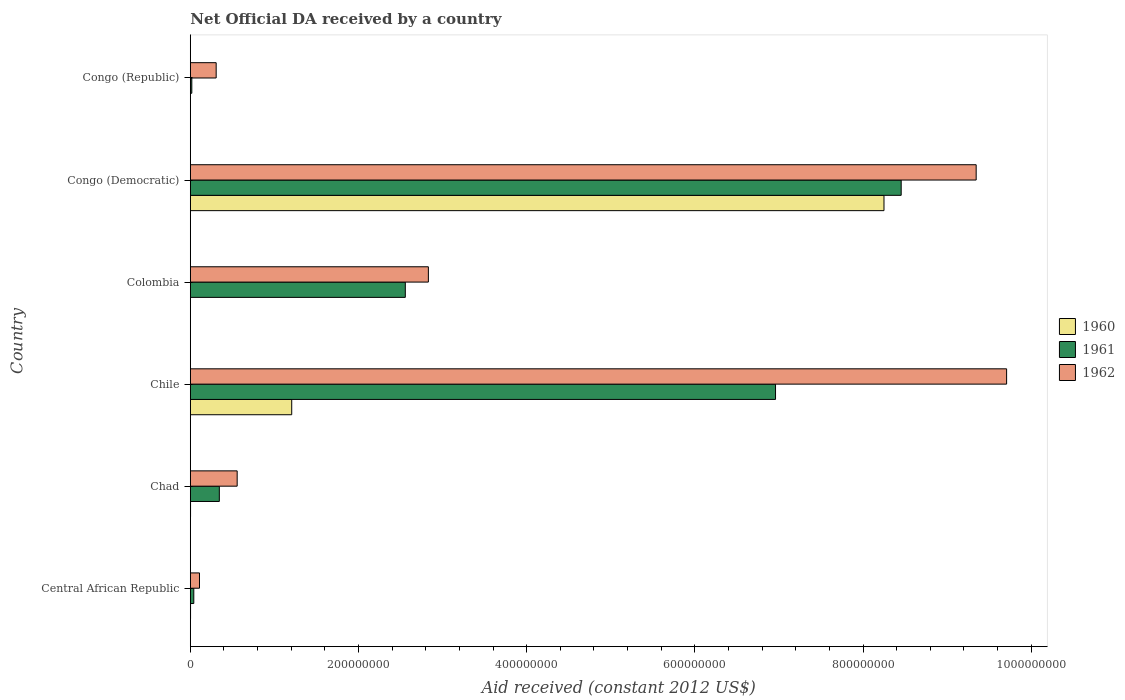How many groups of bars are there?
Make the answer very short. 6. Are the number of bars per tick equal to the number of legend labels?
Offer a very short reply. No. Are the number of bars on each tick of the Y-axis equal?
Make the answer very short. No. What is the label of the 2nd group of bars from the top?
Ensure brevity in your answer.  Congo (Democratic). What is the net official development assistance aid received in 1962 in Colombia?
Provide a succinct answer. 2.83e+08. Across all countries, what is the maximum net official development assistance aid received in 1960?
Provide a short and direct response. 8.25e+08. Across all countries, what is the minimum net official development assistance aid received in 1961?
Ensure brevity in your answer.  1.80e+06. What is the total net official development assistance aid received in 1962 in the graph?
Provide a succinct answer. 2.29e+09. What is the difference between the net official development assistance aid received in 1960 in Central African Republic and that in Congo (Republic)?
Give a very brief answer. 8.00e+04. What is the difference between the net official development assistance aid received in 1960 in Chad and the net official development assistance aid received in 1962 in Colombia?
Your answer should be very brief. -2.83e+08. What is the average net official development assistance aid received in 1960 per country?
Your answer should be very brief. 1.58e+08. What is the difference between the net official development assistance aid received in 1962 and net official development assistance aid received in 1960 in Congo (Democratic)?
Offer a very short reply. 1.10e+08. What is the ratio of the net official development assistance aid received in 1962 in Chile to that in Congo (Democratic)?
Provide a succinct answer. 1.04. Is the difference between the net official development assistance aid received in 1962 in Chile and Congo (Republic) greater than the difference between the net official development assistance aid received in 1960 in Chile and Congo (Republic)?
Offer a terse response. Yes. What is the difference between the highest and the second highest net official development assistance aid received in 1962?
Ensure brevity in your answer.  3.62e+07. What is the difference between the highest and the lowest net official development assistance aid received in 1960?
Give a very brief answer. 8.25e+08. In how many countries, is the net official development assistance aid received in 1960 greater than the average net official development assistance aid received in 1960 taken over all countries?
Give a very brief answer. 1. How many bars are there?
Your answer should be very brief. 17. How many countries are there in the graph?
Provide a succinct answer. 6. Are the values on the major ticks of X-axis written in scientific E-notation?
Your answer should be compact. No. Does the graph contain grids?
Give a very brief answer. No. Where does the legend appear in the graph?
Provide a short and direct response. Center right. How many legend labels are there?
Your answer should be very brief. 3. What is the title of the graph?
Ensure brevity in your answer.  Net Official DA received by a country. What is the label or title of the X-axis?
Your answer should be compact. Aid received (constant 2012 US$). What is the Aid received (constant 2012 US$) in 1961 in Central African Republic?
Provide a short and direct response. 4.17e+06. What is the Aid received (constant 2012 US$) in 1962 in Central African Republic?
Make the answer very short. 1.09e+07. What is the Aid received (constant 2012 US$) in 1960 in Chad?
Make the answer very short. 3.00e+05. What is the Aid received (constant 2012 US$) of 1961 in Chad?
Offer a very short reply. 3.45e+07. What is the Aid received (constant 2012 US$) of 1962 in Chad?
Your answer should be very brief. 5.57e+07. What is the Aid received (constant 2012 US$) in 1960 in Chile?
Give a very brief answer. 1.21e+08. What is the Aid received (constant 2012 US$) in 1961 in Chile?
Provide a succinct answer. 6.96e+08. What is the Aid received (constant 2012 US$) in 1962 in Chile?
Make the answer very short. 9.71e+08. What is the Aid received (constant 2012 US$) in 1961 in Colombia?
Your answer should be compact. 2.56e+08. What is the Aid received (constant 2012 US$) of 1962 in Colombia?
Offer a very short reply. 2.83e+08. What is the Aid received (constant 2012 US$) in 1960 in Congo (Democratic)?
Keep it short and to the point. 8.25e+08. What is the Aid received (constant 2012 US$) in 1961 in Congo (Democratic)?
Keep it short and to the point. 8.45e+08. What is the Aid received (constant 2012 US$) of 1962 in Congo (Democratic)?
Keep it short and to the point. 9.35e+08. What is the Aid received (constant 2012 US$) of 1961 in Congo (Republic)?
Offer a terse response. 1.80e+06. What is the Aid received (constant 2012 US$) of 1962 in Congo (Republic)?
Offer a very short reply. 3.08e+07. Across all countries, what is the maximum Aid received (constant 2012 US$) in 1960?
Ensure brevity in your answer.  8.25e+08. Across all countries, what is the maximum Aid received (constant 2012 US$) in 1961?
Provide a short and direct response. 8.45e+08. Across all countries, what is the maximum Aid received (constant 2012 US$) in 1962?
Keep it short and to the point. 9.71e+08. Across all countries, what is the minimum Aid received (constant 2012 US$) of 1960?
Offer a terse response. 0. Across all countries, what is the minimum Aid received (constant 2012 US$) in 1961?
Provide a short and direct response. 1.80e+06. Across all countries, what is the minimum Aid received (constant 2012 US$) of 1962?
Your answer should be compact. 1.09e+07. What is the total Aid received (constant 2012 US$) of 1960 in the graph?
Provide a short and direct response. 9.46e+08. What is the total Aid received (constant 2012 US$) in 1961 in the graph?
Ensure brevity in your answer.  1.84e+09. What is the total Aid received (constant 2012 US$) of 1962 in the graph?
Offer a very short reply. 2.29e+09. What is the difference between the Aid received (constant 2012 US$) in 1961 in Central African Republic and that in Chad?
Make the answer very short. -3.04e+07. What is the difference between the Aid received (constant 2012 US$) of 1962 in Central African Republic and that in Chad?
Give a very brief answer. -4.48e+07. What is the difference between the Aid received (constant 2012 US$) of 1960 in Central African Republic and that in Chile?
Your answer should be compact. -1.20e+08. What is the difference between the Aid received (constant 2012 US$) of 1961 in Central African Republic and that in Chile?
Your response must be concise. -6.92e+08. What is the difference between the Aid received (constant 2012 US$) in 1962 in Central African Republic and that in Chile?
Provide a succinct answer. -9.60e+08. What is the difference between the Aid received (constant 2012 US$) in 1961 in Central African Republic and that in Colombia?
Keep it short and to the point. -2.52e+08. What is the difference between the Aid received (constant 2012 US$) of 1962 in Central African Republic and that in Colombia?
Offer a terse response. -2.72e+08. What is the difference between the Aid received (constant 2012 US$) in 1960 in Central African Republic and that in Congo (Democratic)?
Offer a very short reply. -8.25e+08. What is the difference between the Aid received (constant 2012 US$) of 1961 in Central African Republic and that in Congo (Democratic)?
Make the answer very short. -8.41e+08. What is the difference between the Aid received (constant 2012 US$) in 1962 in Central African Republic and that in Congo (Democratic)?
Offer a terse response. -9.24e+08. What is the difference between the Aid received (constant 2012 US$) of 1960 in Central African Republic and that in Congo (Republic)?
Ensure brevity in your answer.  8.00e+04. What is the difference between the Aid received (constant 2012 US$) in 1961 in Central African Republic and that in Congo (Republic)?
Offer a terse response. 2.37e+06. What is the difference between the Aid received (constant 2012 US$) in 1962 in Central African Republic and that in Congo (Republic)?
Offer a terse response. -1.98e+07. What is the difference between the Aid received (constant 2012 US$) of 1960 in Chad and that in Chile?
Make the answer very short. -1.20e+08. What is the difference between the Aid received (constant 2012 US$) in 1961 in Chad and that in Chile?
Give a very brief answer. -6.61e+08. What is the difference between the Aid received (constant 2012 US$) of 1962 in Chad and that in Chile?
Keep it short and to the point. -9.15e+08. What is the difference between the Aid received (constant 2012 US$) in 1961 in Chad and that in Colombia?
Your answer should be compact. -2.21e+08. What is the difference between the Aid received (constant 2012 US$) of 1962 in Chad and that in Colombia?
Give a very brief answer. -2.27e+08. What is the difference between the Aid received (constant 2012 US$) of 1960 in Chad and that in Congo (Democratic)?
Your answer should be compact. -8.25e+08. What is the difference between the Aid received (constant 2012 US$) of 1961 in Chad and that in Congo (Democratic)?
Ensure brevity in your answer.  -8.11e+08. What is the difference between the Aid received (constant 2012 US$) of 1962 in Chad and that in Congo (Democratic)?
Provide a short and direct response. -8.79e+08. What is the difference between the Aid received (constant 2012 US$) of 1961 in Chad and that in Congo (Republic)?
Offer a terse response. 3.27e+07. What is the difference between the Aid received (constant 2012 US$) of 1962 in Chad and that in Congo (Republic)?
Your response must be concise. 2.50e+07. What is the difference between the Aid received (constant 2012 US$) of 1961 in Chile and that in Colombia?
Provide a succinct answer. 4.40e+08. What is the difference between the Aid received (constant 2012 US$) in 1962 in Chile and that in Colombia?
Offer a terse response. 6.88e+08. What is the difference between the Aid received (constant 2012 US$) of 1960 in Chile and that in Congo (Democratic)?
Keep it short and to the point. -7.04e+08. What is the difference between the Aid received (constant 2012 US$) of 1961 in Chile and that in Congo (Democratic)?
Make the answer very short. -1.49e+08. What is the difference between the Aid received (constant 2012 US$) in 1962 in Chile and that in Congo (Democratic)?
Your answer should be very brief. 3.62e+07. What is the difference between the Aid received (constant 2012 US$) in 1960 in Chile and that in Congo (Republic)?
Your answer should be compact. 1.20e+08. What is the difference between the Aid received (constant 2012 US$) in 1961 in Chile and that in Congo (Republic)?
Ensure brevity in your answer.  6.94e+08. What is the difference between the Aid received (constant 2012 US$) of 1962 in Chile and that in Congo (Republic)?
Provide a short and direct response. 9.40e+08. What is the difference between the Aid received (constant 2012 US$) in 1961 in Colombia and that in Congo (Democratic)?
Your answer should be very brief. -5.90e+08. What is the difference between the Aid received (constant 2012 US$) in 1962 in Colombia and that in Congo (Democratic)?
Offer a very short reply. -6.51e+08. What is the difference between the Aid received (constant 2012 US$) of 1961 in Colombia and that in Congo (Republic)?
Provide a succinct answer. 2.54e+08. What is the difference between the Aid received (constant 2012 US$) in 1962 in Colombia and that in Congo (Republic)?
Give a very brief answer. 2.52e+08. What is the difference between the Aid received (constant 2012 US$) in 1960 in Congo (Democratic) and that in Congo (Republic)?
Keep it short and to the point. 8.25e+08. What is the difference between the Aid received (constant 2012 US$) in 1961 in Congo (Democratic) and that in Congo (Republic)?
Make the answer very short. 8.44e+08. What is the difference between the Aid received (constant 2012 US$) in 1962 in Congo (Democratic) and that in Congo (Republic)?
Offer a terse response. 9.04e+08. What is the difference between the Aid received (constant 2012 US$) of 1960 in Central African Republic and the Aid received (constant 2012 US$) of 1961 in Chad?
Your answer should be compact. -3.42e+07. What is the difference between the Aid received (constant 2012 US$) in 1960 in Central African Republic and the Aid received (constant 2012 US$) in 1962 in Chad?
Give a very brief answer. -5.54e+07. What is the difference between the Aid received (constant 2012 US$) in 1961 in Central African Republic and the Aid received (constant 2012 US$) in 1962 in Chad?
Provide a succinct answer. -5.16e+07. What is the difference between the Aid received (constant 2012 US$) of 1960 in Central African Republic and the Aid received (constant 2012 US$) of 1961 in Chile?
Make the answer very short. -6.96e+08. What is the difference between the Aid received (constant 2012 US$) of 1960 in Central African Republic and the Aid received (constant 2012 US$) of 1962 in Chile?
Provide a short and direct response. -9.70e+08. What is the difference between the Aid received (constant 2012 US$) of 1961 in Central African Republic and the Aid received (constant 2012 US$) of 1962 in Chile?
Make the answer very short. -9.67e+08. What is the difference between the Aid received (constant 2012 US$) of 1960 in Central African Republic and the Aid received (constant 2012 US$) of 1961 in Colombia?
Provide a short and direct response. -2.55e+08. What is the difference between the Aid received (constant 2012 US$) in 1960 in Central African Republic and the Aid received (constant 2012 US$) in 1962 in Colombia?
Offer a very short reply. -2.83e+08. What is the difference between the Aid received (constant 2012 US$) of 1961 in Central African Republic and the Aid received (constant 2012 US$) of 1962 in Colombia?
Make the answer very short. -2.79e+08. What is the difference between the Aid received (constant 2012 US$) in 1960 in Central African Republic and the Aid received (constant 2012 US$) in 1961 in Congo (Democratic)?
Offer a terse response. -8.45e+08. What is the difference between the Aid received (constant 2012 US$) of 1960 in Central African Republic and the Aid received (constant 2012 US$) of 1962 in Congo (Democratic)?
Make the answer very short. -9.34e+08. What is the difference between the Aid received (constant 2012 US$) in 1961 in Central African Republic and the Aid received (constant 2012 US$) in 1962 in Congo (Democratic)?
Give a very brief answer. -9.30e+08. What is the difference between the Aid received (constant 2012 US$) in 1960 in Central African Republic and the Aid received (constant 2012 US$) in 1961 in Congo (Republic)?
Your response must be concise. -1.50e+06. What is the difference between the Aid received (constant 2012 US$) in 1960 in Central African Republic and the Aid received (constant 2012 US$) in 1962 in Congo (Republic)?
Provide a succinct answer. -3.05e+07. What is the difference between the Aid received (constant 2012 US$) of 1961 in Central African Republic and the Aid received (constant 2012 US$) of 1962 in Congo (Republic)?
Your answer should be very brief. -2.66e+07. What is the difference between the Aid received (constant 2012 US$) of 1960 in Chad and the Aid received (constant 2012 US$) of 1961 in Chile?
Your answer should be very brief. -6.96e+08. What is the difference between the Aid received (constant 2012 US$) in 1960 in Chad and the Aid received (constant 2012 US$) in 1962 in Chile?
Offer a very short reply. -9.70e+08. What is the difference between the Aid received (constant 2012 US$) of 1961 in Chad and the Aid received (constant 2012 US$) of 1962 in Chile?
Your response must be concise. -9.36e+08. What is the difference between the Aid received (constant 2012 US$) of 1960 in Chad and the Aid received (constant 2012 US$) of 1961 in Colombia?
Provide a short and direct response. -2.55e+08. What is the difference between the Aid received (constant 2012 US$) in 1960 in Chad and the Aid received (constant 2012 US$) in 1962 in Colombia?
Offer a terse response. -2.83e+08. What is the difference between the Aid received (constant 2012 US$) in 1961 in Chad and the Aid received (constant 2012 US$) in 1962 in Colombia?
Your answer should be compact. -2.49e+08. What is the difference between the Aid received (constant 2012 US$) of 1960 in Chad and the Aid received (constant 2012 US$) of 1961 in Congo (Democratic)?
Your answer should be very brief. -8.45e+08. What is the difference between the Aid received (constant 2012 US$) of 1960 in Chad and the Aid received (constant 2012 US$) of 1962 in Congo (Democratic)?
Offer a terse response. -9.34e+08. What is the difference between the Aid received (constant 2012 US$) of 1961 in Chad and the Aid received (constant 2012 US$) of 1962 in Congo (Democratic)?
Your answer should be very brief. -9.00e+08. What is the difference between the Aid received (constant 2012 US$) of 1960 in Chad and the Aid received (constant 2012 US$) of 1961 in Congo (Republic)?
Provide a short and direct response. -1.50e+06. What is the difference between the Aid received (constant 2012 US$) in 1960 in Chad and the Aid received (constant 2012 US$) in 1962 in Congo (Republic)?
Ensure brevity in your answer.  -3.05e+07. What is the difference between the Aid received (constant 2012 US$) in 1961 in Chad and the Aid received (constant 2012 US$) in 1962 in Congo (Republic)?
Make the answer very short. 3.75e+06. What is the difference between the Aid received (constant 2012 US$) in 1960 in Chile and the Aid received (constant 2012 US$) in 1961 in Colombia?
Your answer should be very brief. -1.35e+08. What is the difference between the Aid received (constant 2012 US$) of 1960 in Chile and the Aid received (constant 2012 US$) of 1962 in Colombia?
Your answer should be very brief. -1.63e+08. What is the difference between the Aid received (constant 2012 US$) in 1961 in Chile and the Aid received (constant 2012 US$) in 1962 in Colombia?
Your answer should be compact. 4.13e+08. What is the difference between the Aid received (constant 2012 US$) of 1960 in Chile and the Aid received (constant 2012 US$) of 1961 in Congo (Democratic)?
Provide a succinct answer. -7.25e+08. What is the difference between the Aid received (constant 2012 US$) in 1960 in Chile and the Aid received (constant 2012 US$) in 1962 in Congo (Democratic)?
Give a very brief answer. -8.14e+08. What is the difference between the Aid received (constant 2012 US$) in 1961 in Chile and the Aid received (constant 2012 US$) in 1962 in Congo (Democratic)?
Your response must be concise. -2.39e+08. What is the difference between the Aid received (constant 2012 US$) in 1960 in Chile and the Aid received (constant 2012 US$) in 1961 in Congo (Republic)?
Provide a short and direct response. 1.19e+08. What is the difference between the Aid received (constant 2012 US$) in 1960 in Chile and the Aid received (constant 2012 US$) in 1962 in Congo (Republic)?
Make the answer very short. 8.98e+07. What is the difference between the Aid received (constant 2012 US$) in 1961 in Chile and the Aid received (constant 2012 US$) in 1962 in Congo (Republic)?
Provide a short and direct response. 6.65e+08. What is the difference between the Aid received (constant 2012 US$) in 1961 in Colombia and the Aid received (constant 2012 US$) in 1962 in Congo (Democratic)?
Ensure brevity in your answer.  -6.79e+08. What is the difference between the Aid received (constant 2012 US$) in 1961 in Colombia and the Aid received (constant 2012 US$) in 1962 in Congo (Republic)?
Offer a very short reply. 2.25e+08. What is the difference between the Aid received (constant 2012 US$) of 1960 in Congo (Democratic) and the Aid received (constant 2012 US$) of 1961 in Congo (Republic)?
Ensure brevity in your answer.  8.23e+08. What is the difference between the Aid received (constant 2012 US$) in 1960 in Congo (Democratic) and the Aid received (constant 2012 US$) in 1962 in Congo (Republic)?
Give a very brief answer. 7.94e+08. What is the difference between the Aid received (constant 2012 US$) of 1961 in Congo (Democratic) and the Aid received (constant 2012 US$) of 1962 in Congo (Republic)?
Keep it short and to the point. 8.15e+08. What is the average Aid received (constant 2012 US$) of 1960 per country?
Offer a very short reply. 1.58e+08. What is the average Aid received (constant 2012 US$) of 1961 per country?
Provide a succinct answer. 3.06e+08. What is the average Aid received (constant 2012 US$) of 1962 per country?
Your answer should be compact. 3.81e+08. What is the difference between the Aid received (constant 2012 US$) of 1960 and Aid received (constant 2012 US$) of 1961 in Central African Republic?
Keep it short and to the point. -3.87e+06. What is the difference between the Aid received (constant 2012 US$) in 1960 and Aid received (constant 2012 US$) in 1962 in Central African Republic?
Keep it short and to the point. -1.06e+07. What is the difference between the Aid received (constant 2012 US$) of 1961 and Aid received (constant 2012 US$) of 1962 in Central African Republic?
Your answer should be compact. -6.76e+06. What is the difference between the Aid received (constant 2012 US$) of 1960 and Aid received (constant 2012 US$) of 1961 in Chad?
Ensure brevity in your answer.  -3.42e+07. What is the difference between the Aid received (constant 2012 US$) of 1960 and Aid received (constant 2012 US$) of 1962 in Chad?
Your answer should be very brief. -5.54e+07. What is the difference between the Aid received (constant 2012 US$) of 1961 and Aid received (constant 2012 US$) of 1962 in Chad?
Ensure brevity in your answer.  -2.12e+07. What is the difference between the Aid received (constant 2012 US$) in 1960 and Aid received (constant 2012 US$) in 1961 in Chile?
Your answer should be very brief. -5.75e+08. What is the difference between the Aid received (constant 2012 US$) of 1960 and Aid received (constant 2012 US$) of 1962 in Chile?
Provide a succinct answer. -8.50e+08. What is the difference between the Aid received (constant 2012 US$) of 1961 and Aid received (constant 2012 US$) of 1962 in Chile?
Offer a terse response. -2.75e+08. What is the difference between the Aid received (constant 2012 US$) in 1961 and Aid received (constant 2012 US$) in 1962 in Colombia?
Provide a short and direct response. -2.74e+07. What is the difference between the Aid received (constant 2012 US$) in 1960 and Aid received (constant 2012 US$) in 1961 in Congo (Democratic)?
Provide a short and direct response. -2.05e+07. What is the difference between the Aid received (constant 2012 US$) in 1960 and Aid received (constant 2012 US$) in 1962 in Congo (Democratic)?
Give a very brief answer. -1.10e+08. What is the difference between the Aid received (constant 2012 US$) of 1961 and Aid received (constant 2012 US$) of 1962 in Congo (Democratic)?
Provide a succinct answer. -8.92e+07. What is the difference between the Aid received (constant 2012 US$) in 1960 and Aid received (constant 2012 US$) in 1961 in Congo (Republic)?
Make the answer very short. -1.58e+06. What is the difference between the Aid received (constant 2012 US$) in 1960 and Aid received (constant 2012 US$) in 1962 in Congo (Republic)?
Make the answer very short. -3.06e+07. What is the difference between the Aid received (constant 2012 US$) in 1961 and Aid received (constant 2012 US$) in 1962 in Congo (Republic)?
Offer a terse response. -2.90e+07. What is the ratio of the Aid received (constant 2012 US$) in 1960 in Central African Republic to that in Chad?
Your response must be concise. 1. What is the ratio of the Aid received (constant 2012 US$) in 1961 in Central African Republic to that in Chad?
Your answer should be very brief. 0.12. What is the ratio of the Aid received (constant 2012 US$) of 1962 in Central African Republic to that in Chad?
Your answer should be very brief. 0.2. What is the ratio of the Aid received (constant 2012 US$) of 1960 in Central African Republic to that in Chile?
Provide a succinct answer. 0. What is the ratio of the Aid received (constant 2012 US$) of 1961 in Central African Republic to that in Chile?
Your response must be concise. 0.01. What is the ratio of the Aid received (constant 2012 US$) in 1962 in Central African Republic to that in Chile?
Make the answer very short. 0.01. What is the ratio of the Aid received (constant 2012 US$) in 1961 in Central African Republic to that in Colombia?
Ensure brevity in your answer.  0.02. What is the ratio of the Aid received (constant 2012 US$) of 1962 in Central African Republic to that in Colombia?
Offer a terse response. 0.04. What is the ratio of the Aid received (constant 2012 US$) of 1960 in Central African Republic to that in Congo (Democratic)?
Give a very brief answer. 0. What is the ratio of the Aid received (constant 2012 US$) of 1961 in Central African Republic to that in Congo (Democratic)?
Make the answer very short. 0. What is the ratio of the Aid received (constant 2012 US$) in 1962 in Central African Republic to that in Congo (Democratic)?
Ensure brevity in your answer.  0.01. What is the ratio of the Aid received (constant 2012 US$) of 1960 in Central African Republic to that in Congo (Republic)?
Keep it short and to the point. 1.36. What is the ratio of the Aid received (constant 2012 US$) in 1961 in Central African Republic to that in Congo (Republic)?
Provide a succinct answer. 2.32. What is the ratio of the Aid received (constant 2012 US$) of 1962 in Central African Republic to that in Congo (Republic)?
Offer a very short reply. 0.36. What is the ratio of the Aid received (constant 2012 US$) in 1960 in Chad to that in Chile?
Your answer should be very brief. 0. What is the ratio of the Aid received (constant 2012 US$) of 1961 in Chad to that in Chile?
Give a very brief answer. 0.05. What is the ratio of the Aid received (constant 2012 US$) in 1962 in Chad to that in Chile?
Give a very brief answer. 0.06. What is the ratio of the Aid received (constant 2012 US$) of 1961 in Chad to that in Colombia?
Keep it short and to the point. 0.14. What is the ratio of the Aid received (constant 2012 US$) of 1962 in Chad to that in Colombia?
Your answer should be compact. 0.2. What is the ratio of the Aid received (constant 2012 US$) in 1961 in Chad to that in Congo (Democratic)?
Offer a very short reply. 0.04. What is the ratio of the Aid received (constant 2012 US$) of 1962 in Chad to that in Congo (Democratic)?
Provide a short and direct response. 0.06. What is the ratio of the Aid received (constant 2012 US$) of 1960 in Chad to that in Congo (Republic)?
Give a very brief answer. 1.36. What is the ratio of the Aid received (constant 2012 US$) in 1961 in Chad to that in Congo (Republic)?
Keep it short and to the point. 19.18. What is the ratio of the Aid received (constant 2012 US$) of 1962 in Chad to that in Congo (Republic)?
Offer a terse response. 1.81. What is the ratio of the Aid received (constant 2012 US$) of 1961 in Chile to that in Colombia?
Keep it short and to the point. 2.72. What is the ratio of the Aid received (constant 2012 US$) of 1962 in Chile to that in Colombia?
Provide a succinct answer. 3.43. What is the ratio of the Aid received (constant 2012 US$) in 1960 in Chile to that in Congo (Democratic)?
Ensure brevity in your answer.  0.15. What is the ratio of the Aid received (constant 2012 US$) in 1961 in Chile to that in Congo (Democratic)?
Provide a short and direct response. 0.82. What is the ratio of the Aid received (constant 2012 US$) in 1962 in Chile to that in Congo (Democratic)?
Your response must be concise. 1.04. What is the ratio of the Aid received (constant 2012 US$) in 1960 in Chile to that in Congo (Republic)?
Make the answer very short. 548.18. What is the ratio of the Aid received (constant 2012 US$) of 1961 in Chile to that in Congo (Republic)?
Ensure brevity in your answer.  386.62. What is the ratio of the Aid received (constant 2012 US$) of 1962 in Chile to that in Congo (Republic)?
Provide a short and direct response. 31.54. What is the ratio of the Aid received (constant 2012 US$) in 1961 in Colombia to that in Congo (Democratic)?
Your response must be concise. 0.3. What is the ratio of the Aid received (constant 2012 US$) in 1962 in Colombia to that in Congo (Democratic)?
Keep it short and to the point. 0.3. What is the ratio of the Aid received (constant 2012 US$) in 1961 in Colombia to that in Congo (Republic)?
Keep it short and to the point. 142.05. What is the ratio of the Aid received (constant 2012 US$) in 1962 in Colombia to that in Congo (Republic)?
Keep it short and to the point. 9.2. What is the ratio of the Aid received (constant 2012 US$) of 1960 in Congo (Democratic) to that in Congo (Republic)?
Offer a very short reply. 3749.45. What is the ratio of the Aid received (constant 2012 US$) in 1961 in Congo (Democratic) to that in Congo (Republic)?
Provide a short and direct response. 469.64. What is the ratio of the Aid received (constant 2012 US$) of 1962 in Congo (Democratic) to that in Congo (Republic)?
Provide a succinct answer. 30.36. What is the difference between the highest and the second highest Aid received (constant 2012 US$) of 1960?
Provide a short and direct response. 7.04e+08. What is the difference between the highest and the second highest Aid received (constant 2012 US$) of 1961?
Provide a short and direct response. 1.49e+08. What is the difference between the highest and the second highest Aid received (constant 2012 US$) in 1962?
Provide a short and direct response. 3.62e+07. What is the difference between the highest and the lowest Aid received (constant 2012 US$) in 1960?
Your answer should be compact. 8.25e+08. What is the difference between the highest and the lowest Aid received (constant 2012 US$) in 1961?
Make the answer very short. 8.44e+08. What is the difference between the highest and the lowest Aid received (constant 2012 US$) in 1962?
Keep it short and to the point. 9.60e+08. 